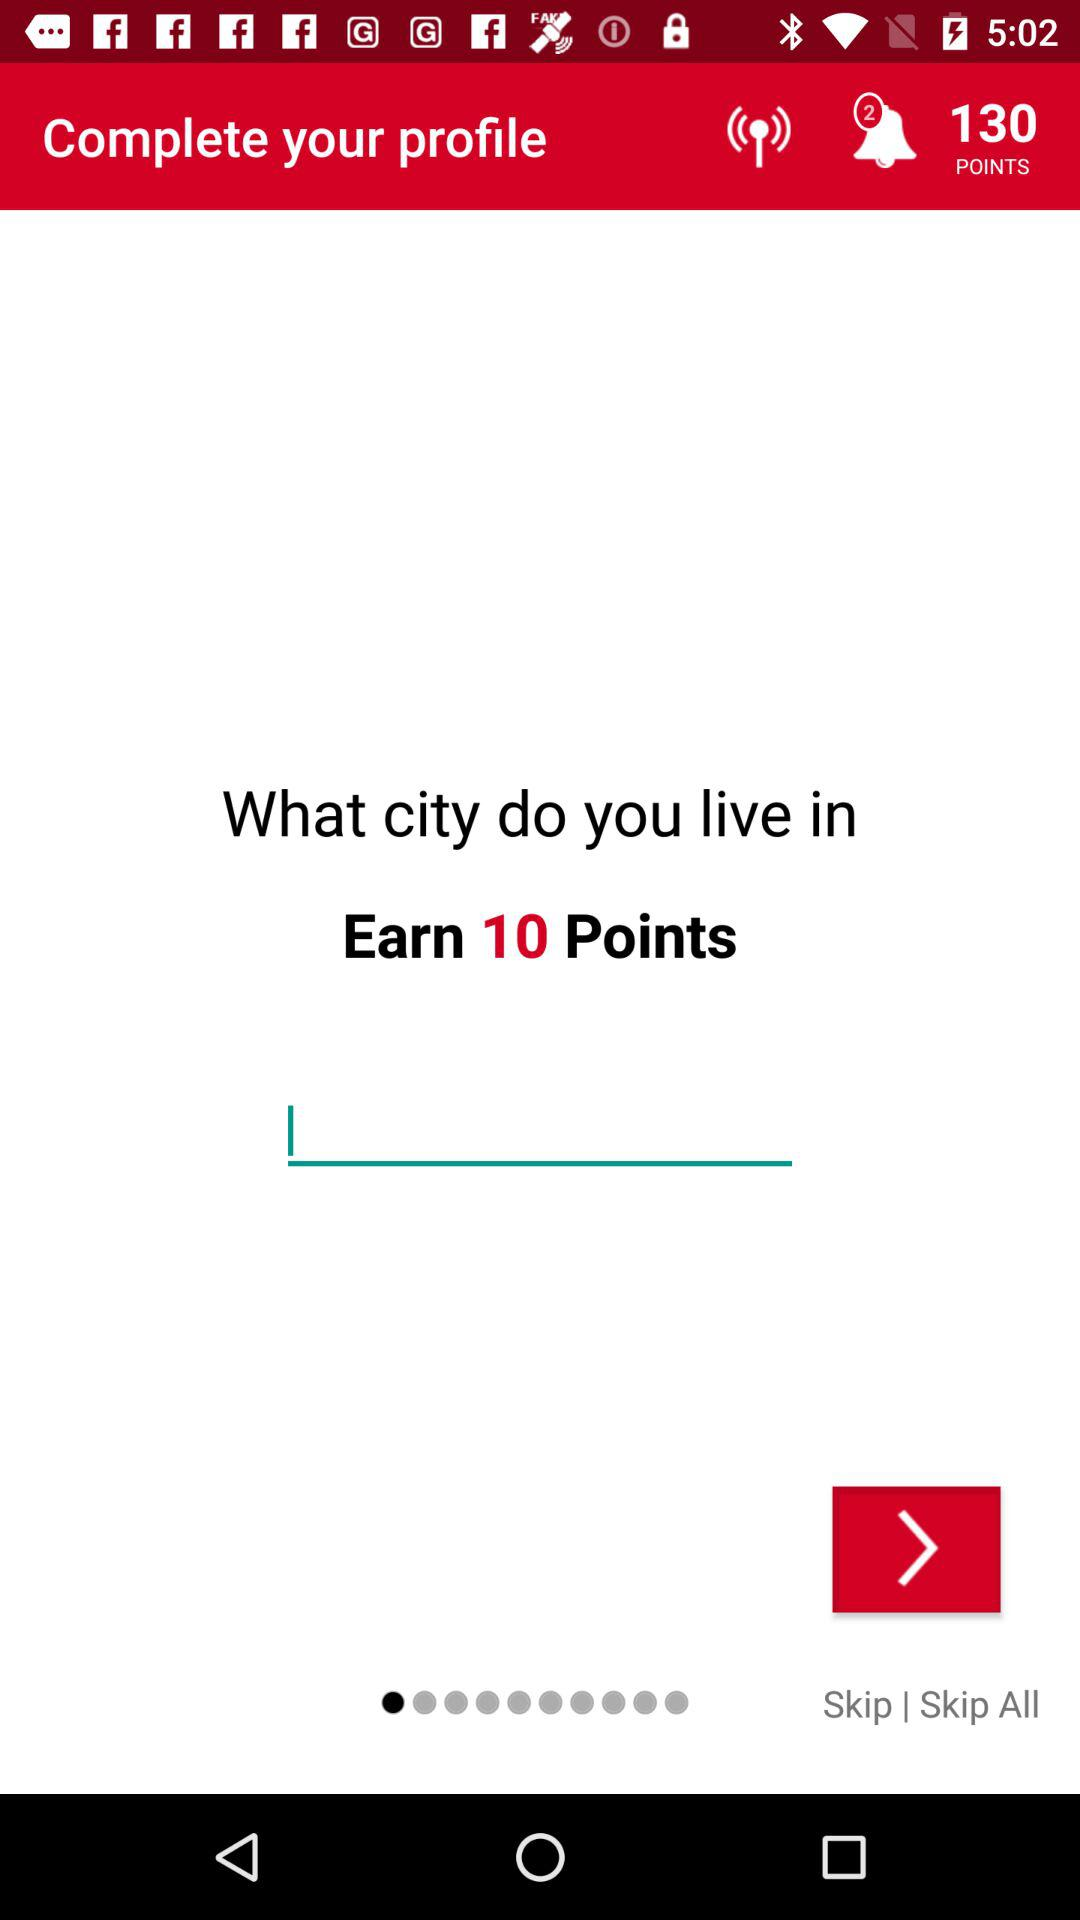How many more points are available for completing the profile than for skipping the question?
Answer the question using a single word or phrase. 10 